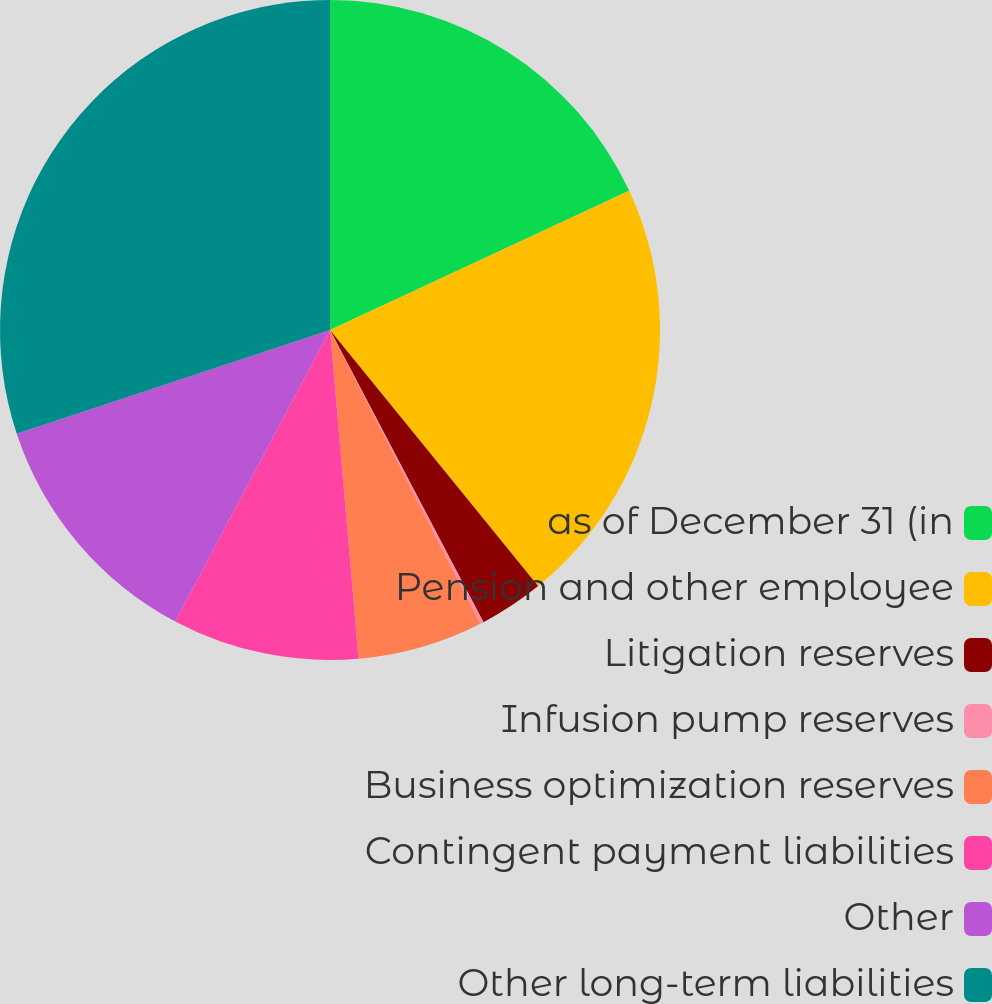Convert chart. <chart><loc_0><loc_0><loc_500><loc_500><pie_chart><fcel>as of December 31 (in<fcel>Pension and other employee<fcel>Litigation reserves<fcel>Infusion pump reserves<fcel>Business optimization reserves<fcel>Contingent payment liabilities<fcel>Other<fcel>Other long-term liabilities<nl><fcel>18.07%<fcel>21.07%<fcel>3.16%<fcel>0.17%<fcel>6.15%<fcel>9.15%<fcel>12.14%<fcel>30.09%<nl></chart> 